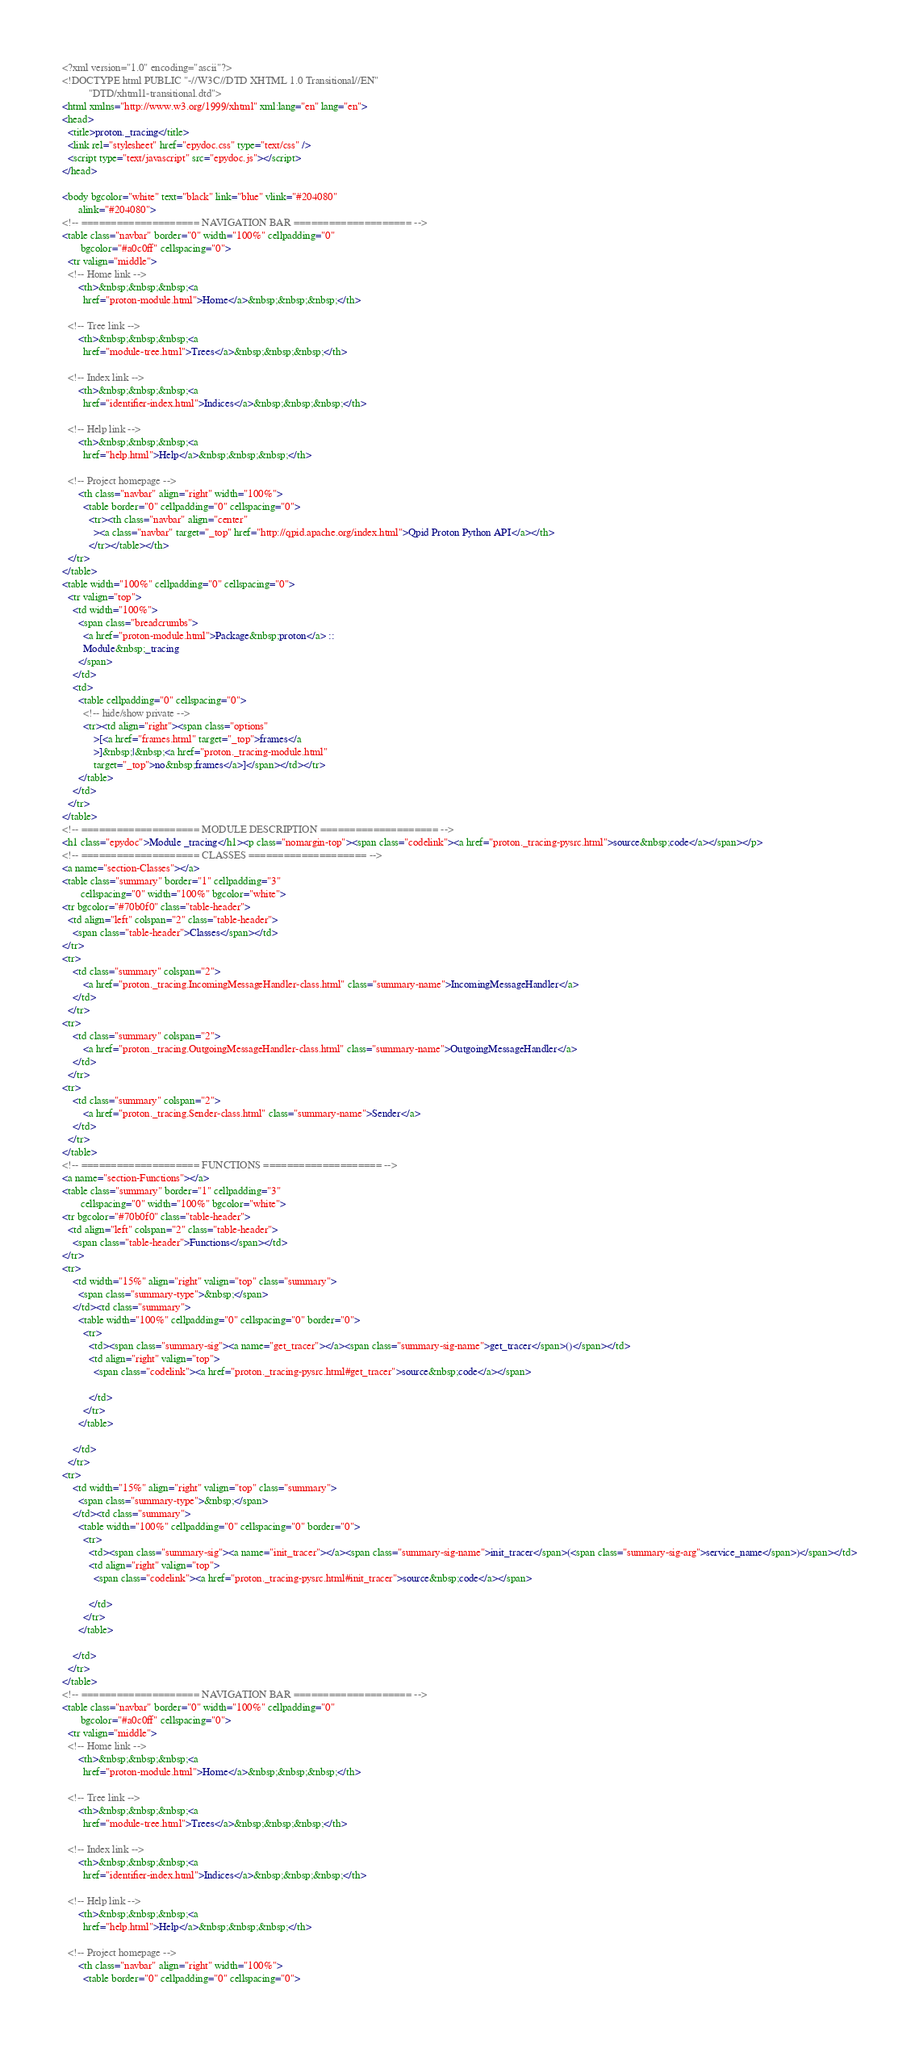Convert code to text. <code><loc_0><loc_0><loc_500><loc_500><_HTML_><?xml version="1.0" encoding="ascii"?>
<!DOCTYPE html PUBLIC "-//W3C//DTD XHTML 1.0 Transitional//EN"
          "DTD/xhtml1-transitional.dtd">
<html xmlns="http://www.w3.org/1999/xhtml" xml:lang="en" lang="en">
<head>
  <title>proton._tracing</title>
  <link rel="stylesheet" href="epydoc.css" type="text/css" />
  <script type="text/javascript" src="epydoc.js"></script>
</head>

<body bgcolor="white" text="black" link="blue" vlink="#204080"
      alink="#204080">
<!-- ==================== NAVIGATION BAR ==================== -->
<table class="navbar" border="0" width="100%" cellpadding="0"
       bgcolor="#a0c0ff" cellspacing="0">
  <tr valign="middle">
  <!-- Home link -->
      <th>&nbsp;&nbsp;&nbsp;<a
        href="proton-module.html">Home</a>&nbsp;&nbsp;&nbsp;</th>

  <!-- Tree link -->
      <th>&nbsp;&nbsp;&nbsp;<a
        href="module-tree.html">Trees</a>&nbsp;&nbsp;&nbsp;</th>

  <!-- Index link -->
      <th>&nbsp;&nbsp;&nbsp;<a
        href="identifier-index.html">Indices</a>&nbsp;&nbsp;&nbsp;</th>

  <!-- Help link -->
      <th>&nbsp;&nbsp;&nbsp;<a
        href="help.html">Help</a>&nbsp;&nbsp;&nbsp;</th>

  <!-- Project homepage -->
      <th class="navbar" align="right" width="100%">
        <table border="0" cellpadding="0" cellspacing="0">
          <tr><th class="navbar" align="center"
            ><a class="navbar" target="_top" href="http://qpid.apache.org/index.html">Qpid Proton Python API</a></th>
          </tr></table></th>
  </tr>
</table>
<table width="100%" cellpadding="0" cellspacing="0">
  <tr valign="top">
    <td width="100%">
      <span class="breadcrumbs">
        <a href="proton-module.html">Package&nbsp;proton</a> ::
        Module&nbsp;_tracing
      </span>
    </td>
    <td>
      <table cellpadding="0" cellspacing="0">
        <!-- hide/show private -->
        <tr><td align="right"><span class="options"
            >[<a href="frames.html" target="_top">frames</a
            >]&nbsp;|&nbsp;<a href="proton._tracing-module.html"
            target="_top">no&nbsp;frames</a>]</span></td></tr>
      </table>
    </td>
  </tr>
</table>
<!-- ==================== MODULE DESCRIPTION ==================== -->
<h1 class="epydoc">Module _tracing</h1><p class="nomargin-top"><span class="codelink"><a href="proton._tracing-pysrc.html">source&nbsp;code</a></span></p>
<!-- ==================== CLASSES ==================== -->
<a name="section-Classes"></a>
<table class="summary" border="1" cellpadding="3"
       cellspacing="0" width="100%" bgcolor="white">
<tr bgcolor="#70b0f0" class="table-header">
  <td align="left" colspan="2" class="table-header">
    <span class="table-header">Classes</span></td>
</tr>
<tr>
    <td class="summary" colspan="2">
        <a href="proton._tracing.IncomingMessageHandler-class.html" class="summary-name">IncomingMessageHandler</a>
    </td>
  </tr>
<tr>
    <td class="summary" colspan="2">
        <a href="proton._tracing.OutgoingMessageHandler-class.html" class="summary-name">OutgoingMessageHandler</a>
    </td>
  </tr>
<tr>
    <td class="summary" colspan="2">
        <a href="proton._tracing.Sender-class.html" class="summary-name">Sender</a>
    </td>
  </tr>
</table>
<!-- ==================== FUNCTIONS ==================== -->
<a name="section-Functions"></a>
<table class="summary" border="1" cellpadding="3"
       cellspacing="0" width="100%" bgcolor="white">
<tr bgcolor="#70b0f0" class="table-header">
  <td align="left" colspan="2" class="table-header">
    <span class="table-header">Functions</span></td>
</tr>
<tr>
    <td width="15%" align="right" valign="top" class="summary">
      <span class="summary-type">&nbsp;</span>
    </td><td class="summary">
      <table width="100%" cellpadding="0" cellspacing="0" border="0">
        <tr>
          <td><span class="summary-sig"><a name="get_tracer"></a><span class="summary-sig-name">get_tracer</span>()</span></td>
          <td align="right" valign="top">
            <span class="codelink"><a href="proton._tracing-pysrc.html#get_tracer">source&nbsp;code</a></span>
            
          </td>
        </tr>
      </table>
      
    </td>
  </tr>
<tr>
    <td width="15%" align="right" valign="top" class="summary">
      <span class="summary-type">&nbsp;</span>
    </td><td class="summary">
      <table width="100%" cellpadding="0" cellspacing="0" border="0">
        <tr>
          <td><span class="summary-sig"><a name="init_tracer"></a><span class="summary-sig-name">init_tracer</span>(<span class="summary-sig-arg">service_name</span>)</span></td>
          <td align="right" valign="top">
            <span class="codelink"><a href="proton._tracing-pysrc.html#init_tracer">source&nbsp;code</a></span>
            
          </td>
        </tr>
      </table>
      
    </td>
  </tr>
</table>
<!-- ==================== NAVIGATION BAR ==================== -->
<table class="navbar" border="0" width="100%" cellpadding="0"
       bgcolor="#a0c0ff" cellspacing="0">
  <tr valign="middle">
  <!-- Home link -->
      <th>&nbsp;&nbsp;&nbsp;<a
        href="proton-module.html">Home</a>&nbsp;&nbsp;&nbsp;</th>

  <!-- Tree link -->
      <th>&nbsp;&nbsp;&nbsp;<a
        href="module-tree.html">Trees</a>&nbsp;&nbsp;&nbsp;</th>

  <!-- Index link -->
      <th>&nbsp;&nbsp;&nbsp;<a
        href="identifier-index.html">Indices</a>&nbsp;&nbsp;&nbsp;</th>

  <!-- Help link -->
      <th>&nbsp;&nbsp;&nbsp;<a
        href="help.html">Help</a>&nbsp;&nbsp;&nbsp;</th>

  <!-- Project homepage -->
      <th class="navbar" align="right" width="100%">
        <table border="0" cellpadding="0" cellspacing="0"></code> 